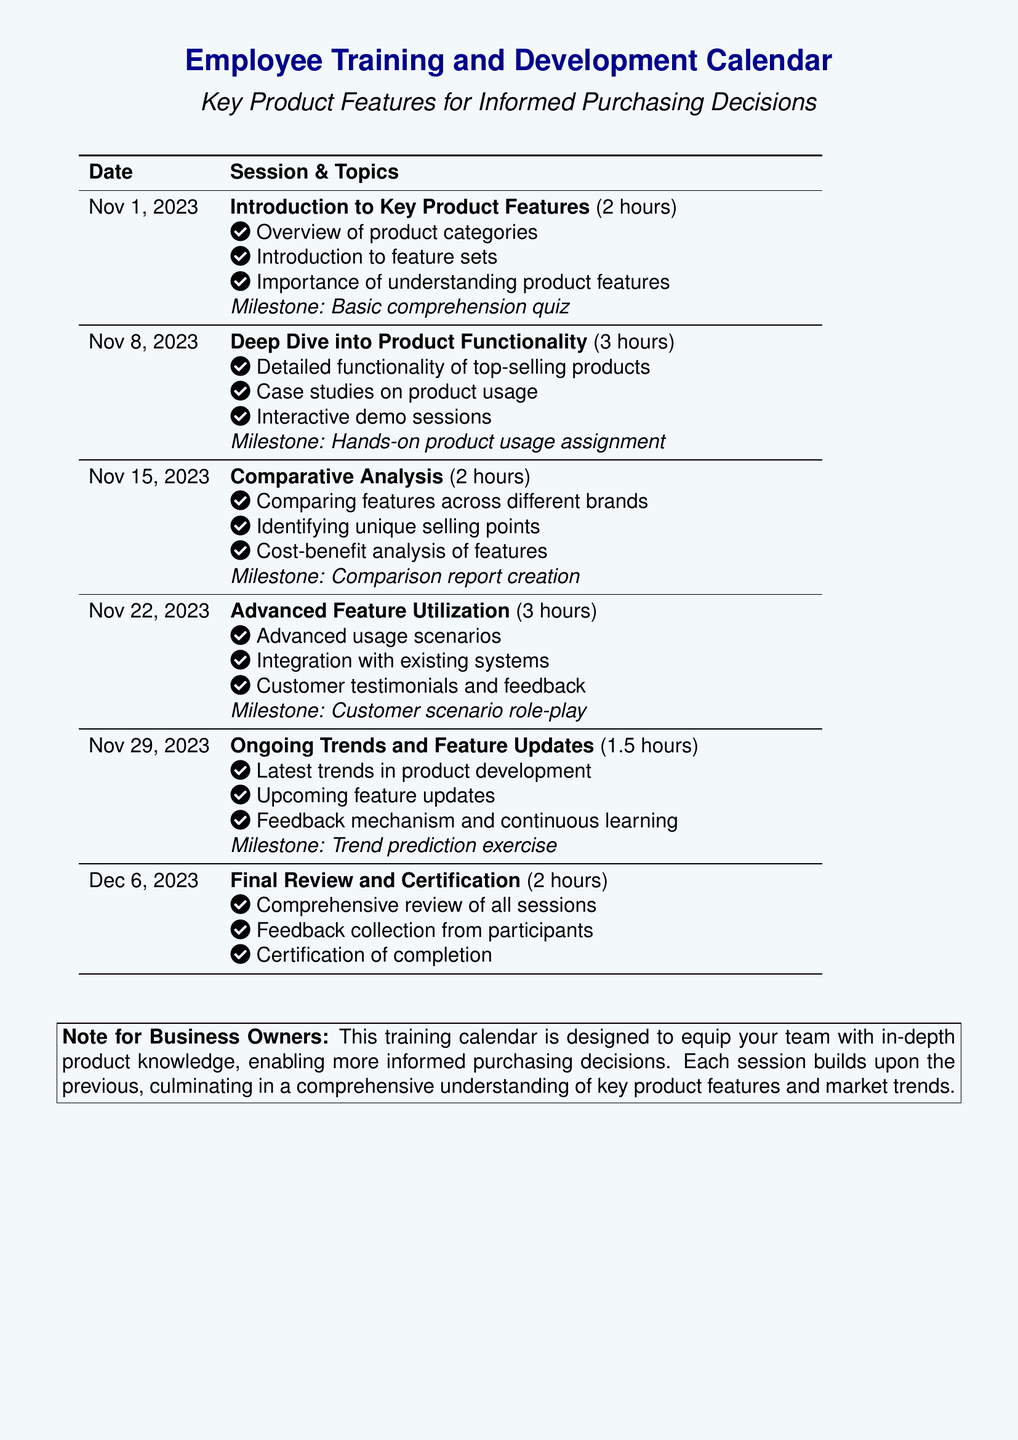What date is the introduction session? The introduction session is scheduled for November 1, 2023.
Answer: November 1, 2023 How long is the deep dive session? The deep dive session lasts for 3 hours.
Answer: 3 hours What type of activities will be included in the milestone for advanced feature utilization? The milestone includes a customer scenario role-play.
Answer: Customer scenario role-play What is a key focus of the session on comparative analysis? A key focus is comparing features across different brands.
Answer: Comparing features across different brands What will participants receive upon completing the final review? Participants will receive a certification of completion.
Answer: Certification of completion How many total sessions are there in the calendar? There are a total of 5 training sessions in the calendar.
Answer: 5 sessions What is the topic of the last session? The last session focuses on the final review and certification.
Answer: Final Review and Certification What is the purpose of the training calendar? The purpose is to equip the team with in-depth product knowledge for informed purchasing decisions.
Answer: Informed purchasing decisions 